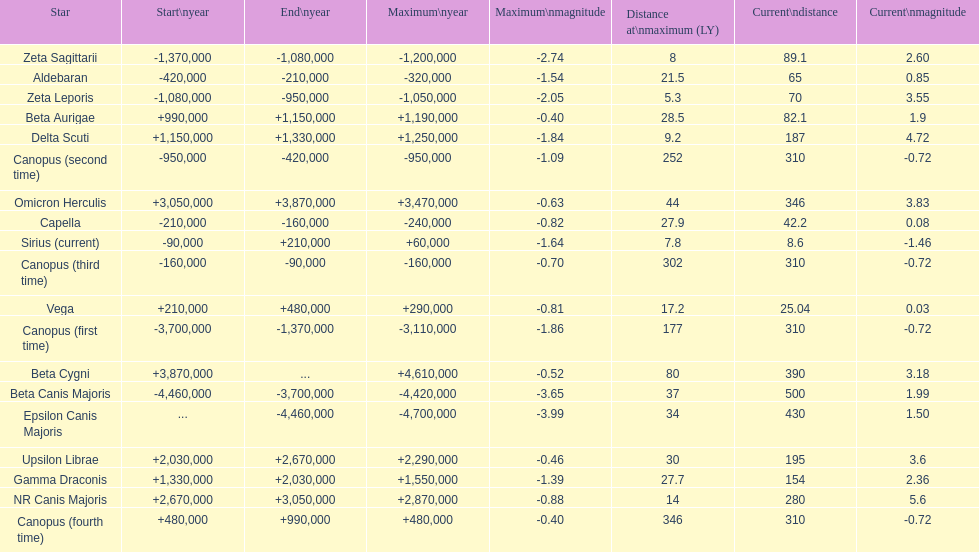How many stars do not have a current magnitude greater than zero? 5. 